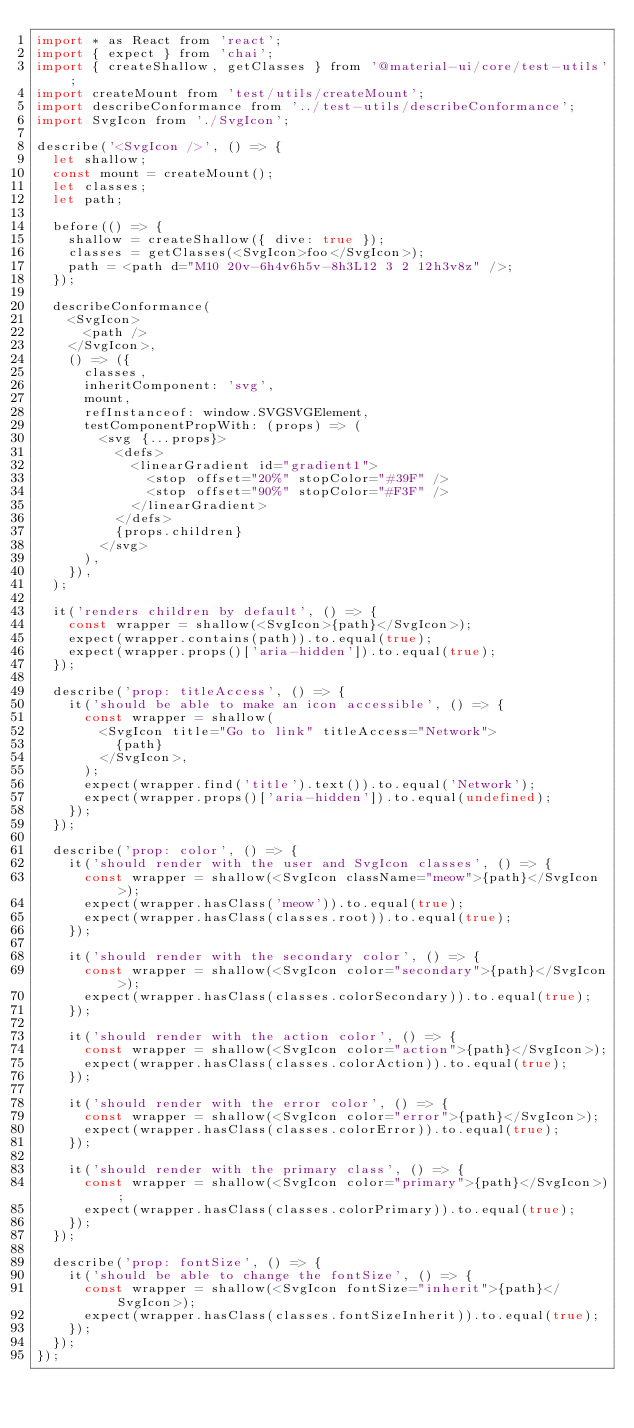Convert code to text. <code><loc_0><loc_0><loc_500><loc_500><_JavaScript_>import * as React from 'react';
import { expect } from 'chai';
import { createShallow, getClasses } from '@material-ui/core/test-utils';
import createMount from 'test/utils/createMount';
import describeConformance from '../test-utils/describeConformance';
import SvgIcon from './SvgIcon';

describe('<SvgIcon />', () => {
  let shallow;
  const mount = createMount();
  let classes;
  let path;

  before(() => {
    shallow = createShallow({ dive: true });
    classes = getClasses(<SvgIcon>foo</SvgIcon>);
    path = <path d="M10 20v-6h4v6h5v-8h3L12 3 2 12h3v8z" />;
  });

  describeConformance(
    <SvgIcon>
      <path />
    </SvgIcon>,
    () => ({
      classes,
      inheritComponent: 'svg',
      mount,
      refInstanceof: window.SVGSVGElement,
      testComponentPropWith: (props) => (
        <svg {...props}>
          <defs>
            <linearGradient id="gradient1">
              <stop offset="20%" stopColor="#39F" />
              <stop offset="90%" stopColor="#F3F" />
            </linearGradient>
          </defs>
          {props.children}
        </svg>
      ),
    }),
  );

  it('renders children by default', () => {
    const wrapper = shallow(<SvgIcon>{path}</SvgIcon>);
    expect(wrapper.contains(path)).to.equal(true);
    expect(wrapper.props()['aria-hidden']).to.equal(true);
  });

  describe('prop: titleAccess', () => {
    it('should be able to make an icon accessible', () => {
      const wrapper = shallow(
        <SvgIcon title="Go to link" titleAccess="Network">
          {path}
        </SvgIcon>,
      );
      expect(wrapper.find('title').text()).to.equal('Network');
      expect(wrapper.props()['aria-hidden']).to.equal(undefined);
    });
  });

  describe('prop: color', () => {
    it('should render with the user and SvgIcon classes', () => {
      const wrapper = shallow(<SvgIcon className="meow">{path}</SvgIcon>);
      expect(wrapper.hasClass('meow')).to.equal(true);
      expect(wrapper.hasClass(classes.root)).to.equal(true);
    });

    it('should render with the secondary color', () => {
      const wrapper = shallow(<SvgIcon color="secondary">{path}</SvgIcon>);
      expect(wrapper.hasClass(classes.colorSecondary)).to.equal(true);
    });

    it('should render with the action color', () => {
      const wrapper = shallow(<SvgIcon color="action">{path}</SvgIcon>);
      expect(wrapper.hasClass(classes.colorAction)).to.equal(true);
    });

    it('should render with the error color', () => {
      const wrapper = shallow(<SvgIcon color="error">{path}</SvgIcon>);
      expect(wrapper.hasClass(classes.colorError)).to.equal(true);
    });

    it('should render with the primary class', () => {
      const wrapper = shallow(<SvgIcon color="primary">{path}</SvgIcon>);
      expect(wrapper.hasClass(classes.colorPrimary)).to.equal(true);
    });
  });

  describe('prop: fontSize', () => {
    it('should be able to change the fontSize', () => {
      const wrapper = shallow(<SvgIcon fontSize="inherit">{path}</SvgIcon>);
      expect(wrapper.hasClass(classes.fontSizeInherit)).to.equal(true);
    });
  });
});
</code> 